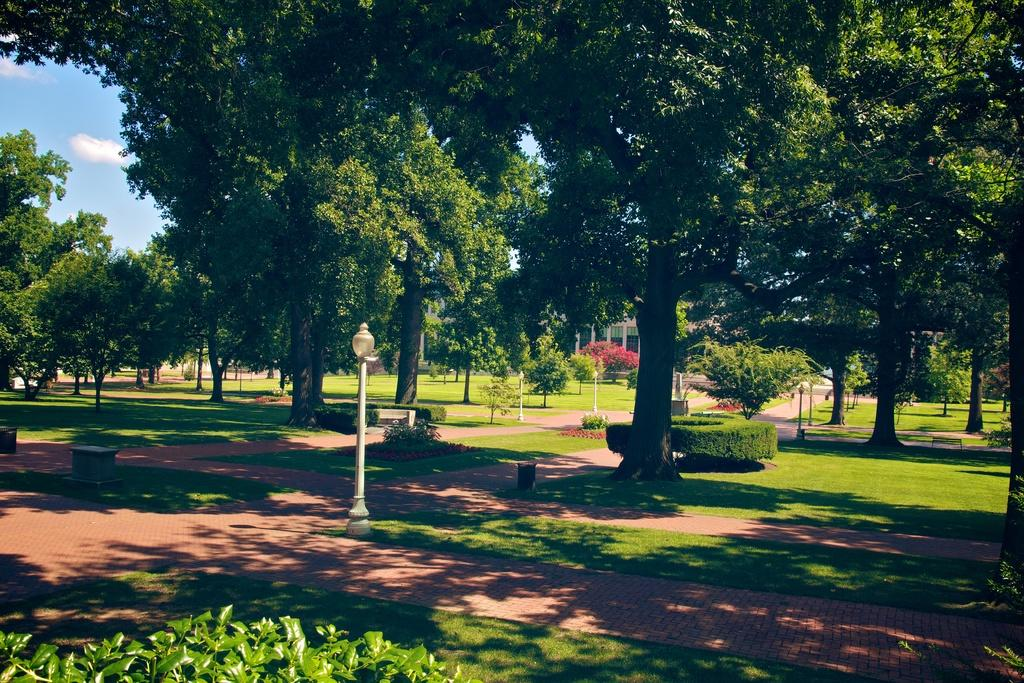What type of vegetation can be seen in the image? There are trees and plants in the image. What type of structures are present in the image? There are buildings and light poles in the image. What type of seating is available in the image? There is a bench in the image. What is on the ground in the image? There are stones on the ground in the image. What is visible in the sky at the top of the image? There are clouds in the sky at the top of the image. What type of oatmeal is being served on the bench in the image? There is no oatmeal present in the image; it features trees, plants, buildings, light poles, a bench, stones, and clouds. What is the acoustics like in the image? The provided facts do not give any information about the acoustics in the image. 